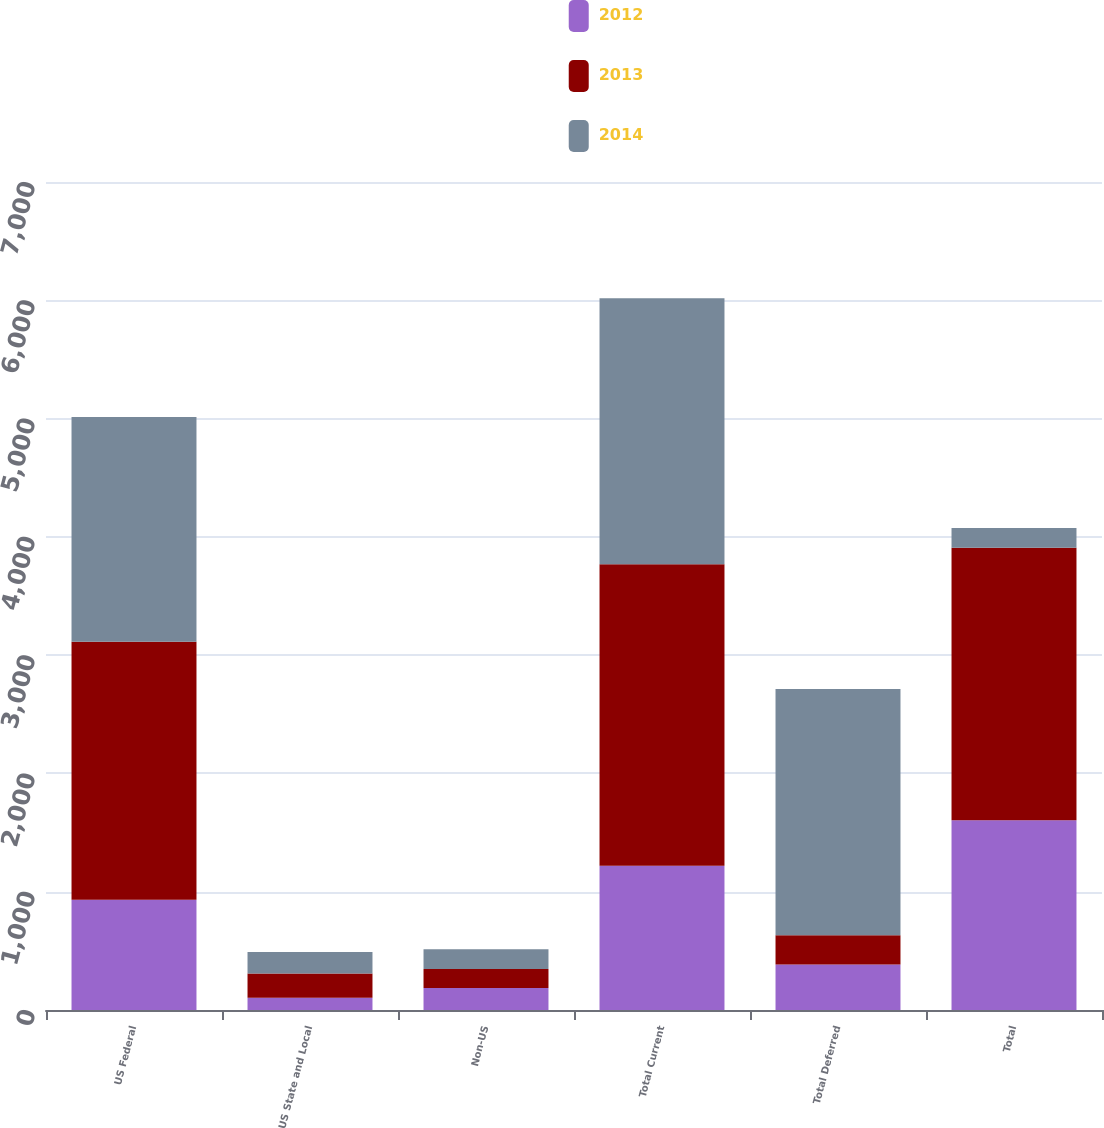Convert chart. <chart><loc_0><loc_0><loc_500><loc_500><stacked_bar_chart><ecel><fcel>US Federal<fcel>US State and Local<fcel>Non-US<fcel>Total Current<fcel>Total Deferred<fcel>Total<nl><fcel>2012<fcel>932<fcel>103<fcel>185<fcel>1220<fcel>385<fcel>1605<nl><fcel>2013<fcel>2181<fcel>205<fcel>162<fcel>2548<fcel>246<fcel>2302<nl><fcel>2014<fcel>1901<fcel>182<fcel>167<fcel>2250<fcel>2083<fcel>167<nl></chart> 